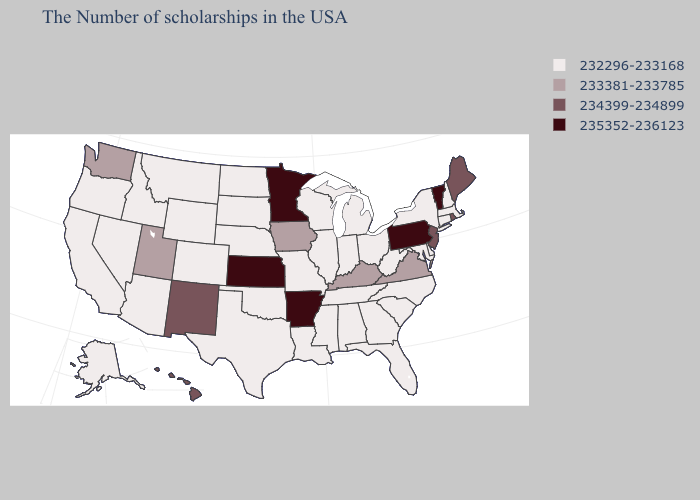Which states have the lowest value in the West?
Concise answer only. Wyoming, Colorado, Montana, Arizona, Idaho, Nevada, California, Oregon, Alaska. Name the states that have a value in the range 233381-233785?
Answer briefly. Virginia, Kentucky, Iowa, Utah, Washington. Name the states that have a value in the range 233381-233785?
Be succinct. Virginia, Kentucky, Iowa, Utah, Washington. What is the value of Delaware?
Be succinct. 232296-233168. Name the states that have a value in the range 234399-234899?
Give a very brief answer. Maine, Rhode Island, New Jersey, New Mexico, Hawaii. Does Virginia have a higher value than Kentucky?
Short answer required. No. Among the states that border Virginia , which have the lowest value?
Keep it brief. Maryland, North Carolina, West Virginia, Tennessee. How many symbols are there in the legend?
Give a very brief answer. 4. Does Kentucky have the lowest value in the USA?
Be succinct. No. What is the value of Nevada?
Write a very short answer. 232296-233168. Is the legend a continuous bar?
Answer briefly. No. What is the lowest value in the MidWest?
Give a very brief answer. 232296-233168. Does Tennessee have a lower value than Missouri?
Be succinct. No. Name the states that have a value in the range 234399-234899?
Write a very short answer. Maine, Rhode Island, New Jersey, New Mexico, Hawaii. Among the states that border North Dakota , does South Dakota have the lowest value?
Give a very brief answer. Yes. 